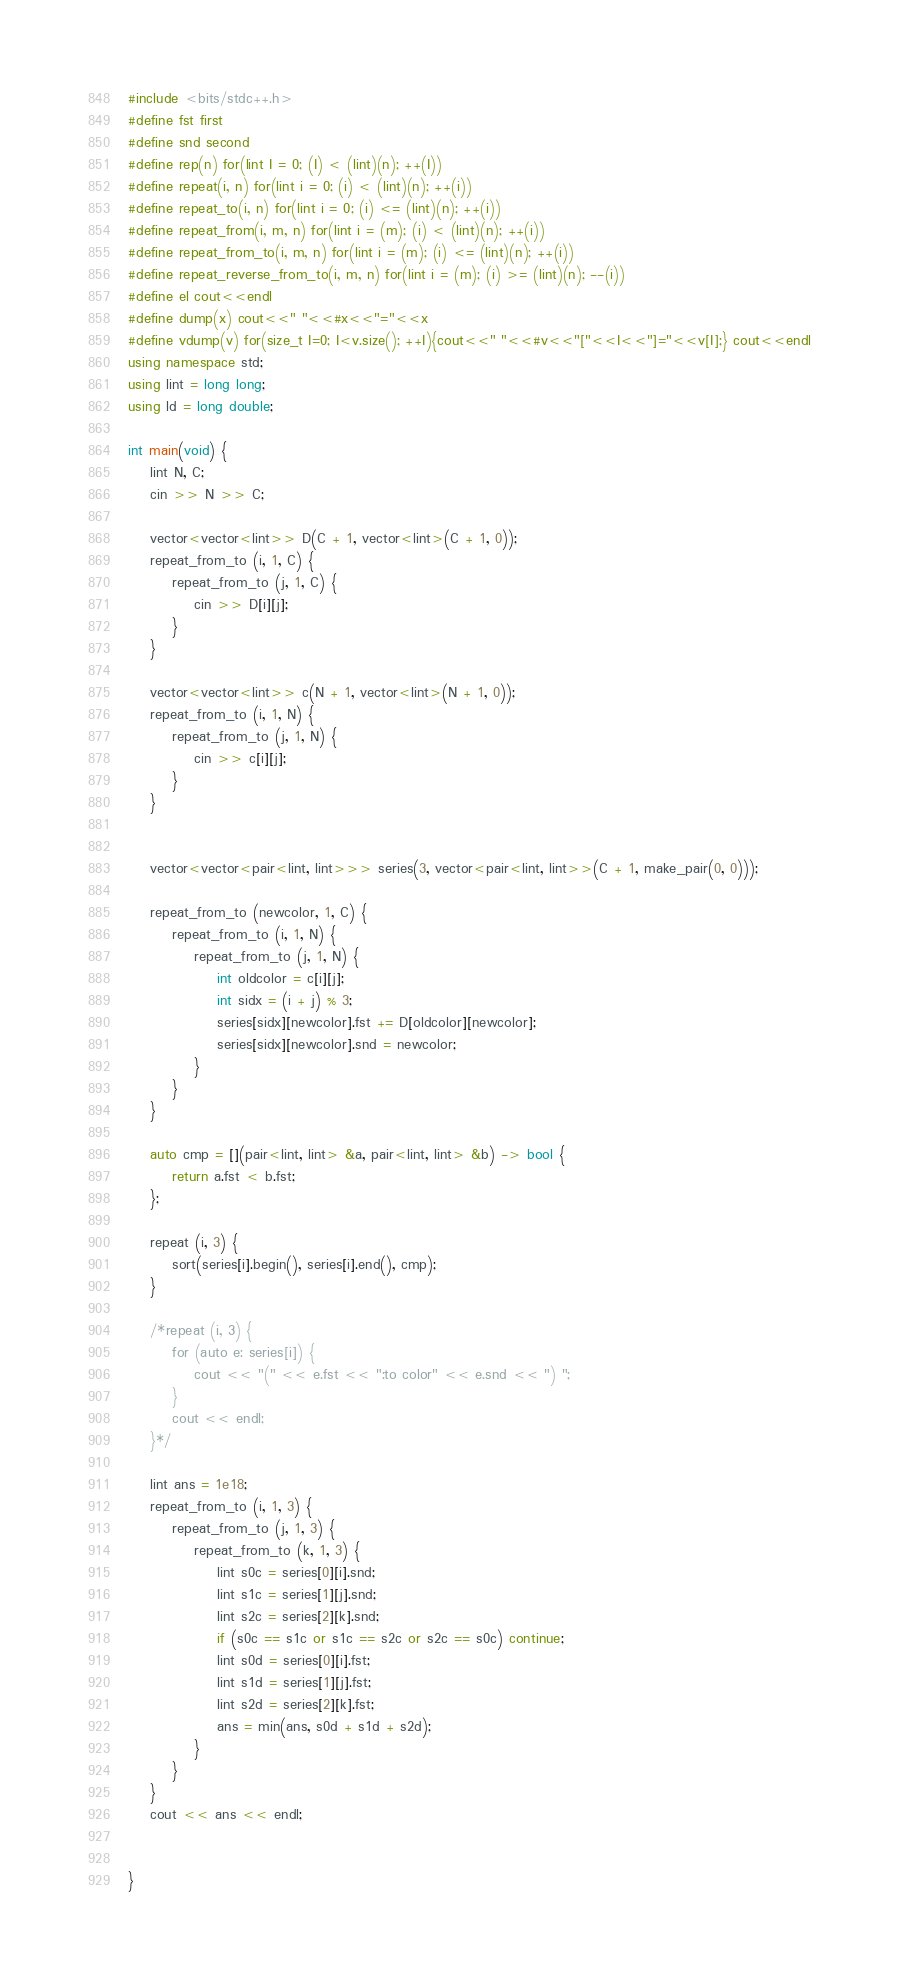<code> <loc_0><loc_0><loc_500><loc_500><_C++_>#include <bits/stdc++.h>
#define fst first
#define snd second
#define rep(n) for(lint I = 0; (I) < (lint)(n); ++(I))
#define repeat(i, n) for(lint i = 0; (i) < (lint)(n); ++(i))
#define repeat_to(i, n) for(lint i = 0; (i) <= (lint)(n); ++(i))
#define repeat_from(i, m, n) for(lint i = (m); (i) < (lint)(n); ++(i))
#define repeat_from_to(i, m, n) for(lint i = (m); (i) <= (lint)(n); ++(i))
#define repeat_reverse_from_to(i, m, n) for(lint i = (m); (i) >= (lint)(n); --(i))
#define el cout<<endl
#define dump(x) cout<<" "<<#x<<"="<<x
#define vdump(v) for(size_t I=0; I<v.size(); ++I){cout<<" "<<#v<<"["<<I<<"]="<<v[I];} cout<<endl
using namespace std;
using lint = long long;
using ld = long double;

int main(void) {
    lint N, C;
    cin >> N >> C;
    
    vector<vector<lint>> D(C + 1, vector<lint>(C + 1, 0));
    repeat_from_to (i, 1, C) {
        repeat_from_to (j, 1, C) {
            cin >> D[i][j];
        }
    }
    
    vector<vector<lint>> c(N + 1, vector<lint>(N + 1, 0));
    repeat_from_to (i, 1, N) {
        repeat_from_to (j, 1, N) {
            cin >> c[i][j];
        }
    }
    
    
    vector<vector<pair<lint, lint>>> series(3, vector<pair<lint, lint>>(C + 1, make_pair(0, 0)));
    
    repeat_from_to (newcolor, 1, C) {
        repeat_from_to (i, 1, N) {
            repeat_from_to (j, 1, N) {
                int oldcolor = c[i][j];
                int sidx = (i + j) % 3;
                series[sidx][newcolor].fst += D[oldcolor][newcolor];
                series[sidx][newcolor].snd = newcolor;
            }
        }
    }
    
    auto cmp = [](pair<lint, lint> &a, pair<lint, lint> &b) -> bool {
        return a.fst < b.fst;
    };
    
    repeat (i, 3) {
        sort(series[i].begin(), series[i].end(), cmp);
    }
    
    /*repeat (i, 3) {
        for (auto e: series[i]) {
            cout << "(" << e.fst << ":to color" << e.snd << ") ";
        }
        cout << endl;
    }*/
    
    lint ans = 1e18;
    repeat_from_to (i, 1, 3) {
        repeat_from_to (j, 1, 3) {
            repeat_from_to (k, 1, 3) {
                lint s0c = series[0][i].snd;
                lint s1c = series[1][j].snd;
                lint s2c = series[2][k].snd;
                if (s0c == s1c or s1c == s2c or s2c == s0c) continue;
                lint s0d = series[0][i].fst;
                lint s1d = series[1][j].fst;
                lint s2d = series[2][k].fst;
                ans = min(ans, s0d + s1d + s2d);
            }
        }
    }
    cout << ans << endl;
                
                
}</code> 